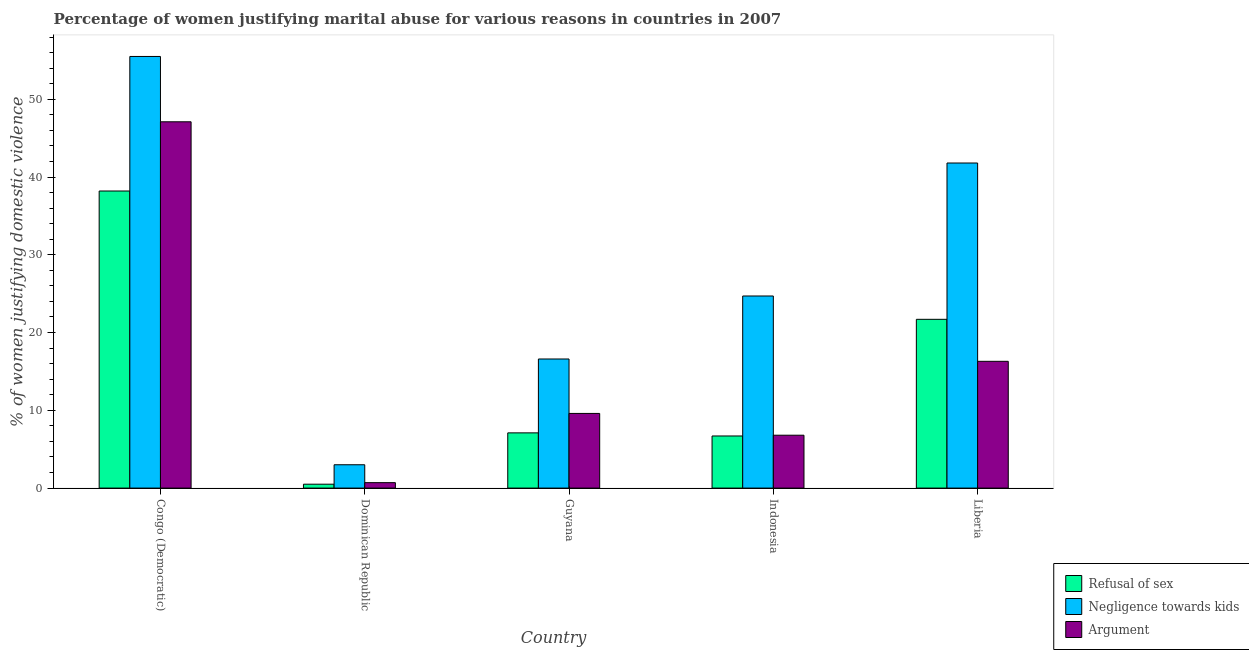How many different coloured bars are there?
Offer a terse response. 3. How many groups of bars are there?
Provide a succinct answer. 5. Are the number of bars per tick equal to the number of legend labels?
Ensure brevity in your answer.  Yes. How many bars are there on the 5th tick from the left?
Provide a short and direct response. 3. How many bars are there on the 3rd tick from the right?
Offer a terse response. 3. What is the label of the 2nd group of bars from the left?
Ensure brevity in your answer.  Dominican Republic. Across all countries, what is the maximum percentage of women justifying domestic violence due to negligence towards kids?
Provide a succinct answer. 55.5. Across all countries, what is the minimum percentage of women justifying domestic violence due to arguments?
Keep it short and to the point. 0.7. In which country was the percentage of women justifying domestic violence due to arguments maximum?
Ensure brevity in your answer.  Congo (Democratic). In which country was the percentage of women justifying domestic violence due to arguments minimum?
Your answer should be compact. Dominican Republic. What is the total percentage of women justifying domestic violence due to arguments in the graph?
Your answer should be compact. 80.5. What is the difference between the percentage of women justifying domestic violence due to refusal of sex in Indonesia and the percentage of women justifying domestic violence due to arguments in Congo (Democratic)?
Make the answer very short. -40.4. What is the ratio of the percentage of women justifying domestic violence due to arguments in Congo (Democratic) to that in Guyana?
Ensure brevity in your answer.  4.91. What is the difference between the highest and the second highest percentage of women justifying domestic violence due to negligence towards kids?
Your response must be concise. 13.7. What is the difference between the highest and the lowest percentage of women justifying domestic violence due to refusal of sex?
Ensure brevity in your answer.  37.7. Is the sum of the percentage of women justifying domestic violence due to arguments in Dominican Republic and Guyana greater than the maximum percentage of women justifying domestic violence due to refusal of sex across all countries?
Provide a succinct answer. No. What does the 1st bar from the left in Indonesia represents?
Make the answer very short. Refusal of sex. What does the 3rd bar from the right in Dominican Republic represents?
Provide a succinct answer. Refusal of sex. What is the difference between two consecutive major ticks on the Y-axis?
Offer a very short reply. 10. Does the graph contain any zero values?
Ensure brevity in your answer.  No. Does the graph contain grids?
Provide a short and direct response. No. How are the legend labels stacked?
Make the answer very short. Vertical. What is the title of the graph?
Your answer should be compact. Percentage of women justifying marital abuse for various reasons in countries in 2007. Does "Food" appear as one of the legend labels in the graph?
Give a very brief answer. No. What is the label or title of the X-axis?
Ensure brevity in your answer.  Country. What is the label or title of the Y-axis?
Make the answer very short. % of women justifying domestic violence. What is the % of women justifying domestic violence in Refusal of sex in Congo (Democratic)?
Offer a very short reply. 38.2. What is the % of women justifying domestic violence of Negligence towards kids in Congo (Democratic)?
Provide a succinct answer. 55.5. What is the % of women justifying domestic violence in Argument in Congo (Democratic)?
Your response must be concise. 47.1. What is the % of women justifying domestic violence in Refusal of sex in Dominican Republic?
Your answer should be very brief. 0.5. What is the % of women justifying domestic violence of Argument in Dominican Republic?
Offer a very short reply. 0.7. What is the % of women justifying domestic violence of Negligence towards kids in Guyana?
Ensure brevity in your answer.  16.6. What is the % of women justifying domestic violence of Refusal of sex in Indonesia?
Your answer should be very brief. 6.7. What is the % of women justifying domestic violence of Negligence towards kids in Indonesia?
Ensure brevity in your answer.  24.7. What is the % of women justifying domestic violence in Argument in Indonesia?
Your response must be concise. 6.8. What is the % of women justifying domestic violence in Refusal of sex in Liberia?
Your response must be concise. 21.7. What is the % of women justifying domestic violence of Negligence towards kids in Liberia?
Provide a succinct answer. 41.8. Across all countries, what is the maximum % of women justifying domestic violence of Refusal of sex?
Your answer should be very brief. 38.2. Across all countries, what is the maximum % of women justifying domestic violence in Negligence towards kids?
Offer a very short reply. 55.5. Across all countries, what is the maximum % of women justifying domestic violence of Argument?
Provide a short and direct response. 47.1. Across all countries, what is the minimum % of women justifying domestic violence of Refusal of sex?
Make the answer very short. 0.5. What is the total % of women justifying domestic violence of Refusal of sex in the graph?
Your response must be concise. 74.2. What is the total % of women justifying domestic violence in Negligence towards kids in the graph?
Keep it short and to the point. 141.6. What is the total % of women justifying domestic violence in Argument in the graph?
Provide a short and direct response. 80.5. What is the difference between the % of women justifying domestic violence of Refusal of sex in Congo (Democratic) and that in Dominican Republic?
Provide a succinct answer. 37.7. What is the difference between the % of women justifying domestic violence of Negligence towards kids in Congo (Democratic) and that in Dominican Republic?
Ensure brevity in your answer.  52.5. What is the difference between the % of women justifying domestic violence of Argument in Congo (Democratic) and that in Dominican Republic?
Offer a terse response. 46.4. What is the difference between the % of women justifying domestic violence in Refusal of sex in Congo (Democratic) and that in Guyana?
Provide a short and direct response. 31.1. What is the difference between the % of women justifying domestic violence in Negligence towards kids in Congo (Democratic) and that in Guyana?
Offer a very short reply. 38.9. What is the difference between the % of women justifying domestic violence of Argument in Congo (Democratic) and that in Guyana?
Offer a terse response. 37.5. What is the difference between the % of women justifying domestic violence of Refusal of sex in Congo (Democratic) and that in Indonesia?
Provide a succinct answer. 31.5. What is the difference between the % of women justifying domestic violence in Negligence towards kids in Congo (Democratic) and that in Indonesia?
Offer a very short reply. 30.8. What is the difference between the % of women justifying domestic violence of Argument in Congo (Democratic) and that in Indonesia?
Provide a short and direct response. 40.3. What is the difference between the % of women justifying domestic violence of Negligence towards kids in Congo (Democratic) and that in Liberia?
Make the answer very short. 13.7. What is the difference between the % of women justifying domestic violence in Argument in Congo (Democratic) and that in Liberia?
Offer a terse response. 30.8. What is the difference between the % of women justifying domestic violence in Refusal of sex in Dominican Republic and that in Guyana?
Give a very brief answer. -6.6. What is the difference between the % of women justifying domestic violence in Negligence towards kids in Dominican Republic and that in Indonesia?
Provide a succinct answer. -21.7. What is the difference between the % of women justifying domestic violence in Refusal of sex in Dominican Republic and that in Liberia?
Ensure brevity in your answer.  -21.2. What is the difference between the % of women justifying domestic violence of Negligence towards kids in Dominican Republic and that in Liberia?
Your answer should be very brief. -38.8. What is the difference between the % of women justifying domestic violence of Argument in Dominican Republic and that in Liberia?
Your answer should be very brief. -15.6. What is the difference between the % of women justifying domestic violence of Negligence towards kids in Guyana and that in Indonesia?
Make the answer very short. -8.1. What is the difference between the % of women justifying domestic violence of Refusal of sex in Guyana and that in Liberia?
Make the answer very short. -14.6. What is the difference between the % of women justifying domestic violence in Negligence towards kids in Guyana and that in Liberia?
Provide a succinct answer. -25.2. What is the difference between the % of women justifying domestic violence in Argument in Guyana and that in Liberia?
Keep it short and to the point. -6.7. What is the difference between the % of women justifying domestic violence of Refusal of sex in Indonesia and that in Liberia?
Give a very brief answer. -15. What is the difference between the % of women justifying domestic violence of Negligence towards kids in Indonesia and that in Liberia?
Give a very brief answer. -17.1. What is the difference between the % of women justifying domestic violence in Refusal of sex in Congo (Democratic) and the % of women justifying domestic violence in Negligence towards kids in Dominican Republic?
Your response must be concise. 35.2. What is the difference between the % of women justifying domestic violence in Refusal of sex in Congo (Democratic) and the % of women justifying domestic violence in Argument in Dominican Republic?
Give a very brief answer. 37.5. What is the difference between the % of women justifying domestic violence in Negligence towards kids in Congo (Democratic) and the % of women justifying domestic violence in Argument in Dominican Republic?
Provide a short and direct response. 54.8. What is the difference between the % of women justifying domestic violence of Refusal of sex in Congo (Democratic) and the % of women justifying domestic violence of Negligence towards kids in Guyana?
Keep it short and to the point. 21.6. What is the difference between the % of women justifying domestic violence of Refusal of sex in Congo (Democratic) and the % of women justifying domestic violence of Argument in Guyana?
Offer a very short reply. 28.6. What is the difference between the % of women justifying domestic violence of Negligence towards kids in Congo (Democratic) and the % of women justifying domestic violence of Argument in Guyana?
Provide a succinct answer. 45.9. What is the difference between the % of women justifying domestic violence of Refusal of sex in Congo (Democratic) and the % of women justifying domestic violence of Argument in Indonesia?
Your response must be concise. 31.4. What is the difference between the % of women justifying domestic violence in Negligence towards kids in Congo (Democratic) and the % of women justifying domestic violence in Argument in Indonesia?
Offer a very short reply. 48.7. What is the difference between the % of women justifying domestic violence of Refusal of sex in Congo (Democratic) and the % of women justifying domestic violence of Argument in Liberia?
Keep it short and to the point. 21.9. What is the difference between the % of women justifying domestic violence of Negligence towards kids in Congo (Democratic) and the % of women justifying domestic violence of Argument in Liberia?
Give a very brief answer. 39.2. What is the difference between the % of women justifying domestic violence in Refusal of sex in Dominican Republic and the % of women justifying domestic violence in Negligence towards kids in Guyana?
Give a very brief answer. -16.1. What is the difference between the % of women justifying domestic violence of Refusal of sex in Dominican Republic and the % of women justifying domestic violence of Argument in Guyana?
Offer a very short reply. -9.1. What is the difference between the % of women justifying domestic violence of Refusal of sex in Dominican Republic and the % of women justifying domestic violence of Negligence towards kids in Indonesia?
Give a very brief answer. -24.2. What is the difference between the % of women justifying domestic violence of Refusal of sex in Dominican Republic and the % of women justifying domestic violence of Argument in Indonesia?
Your answer should be very brief. -6.3. What is the difference between the % of women justifying domestic violence in Refusal of sex in Dominican Republic and the % of women justifying domestic violence in Negligence towards kids in Liberia?
Provide a succinct answer. -41.3. What is the difference between the % of women justifying domestic violence of Refusal of sex in Dominican Republic and the % of women justifying domestic violence of Argument in Liberia?
Ensure brevity in your answer.  -15.8. What is the difference between the % of women justifying domestic violence of Negligence towards kids in Dominican Republic and the % of women justifying domestic violence of Argument in Liberia?
Your response must be concise. -13.3. What is the difference between the % of women justifying domestic violence in Refusal of sex in Guyana and the % of women justifying domestic violence in Negligence towards kids in Indonesia?
Offer a very short reply. -17.6. What is the difference between the % of women justifying domestic violence of Negligence towards kids in Guyana and the % of women justifying domestic violence of Argument in Indonesia?
Ensure brevity in your answer.  9.8. What is the difference between the % of women justifying domestic violence in Refusal of sex in Guyana and the % of women justifying domestic violence in Negligence towards kids in Liberia?
Give a very brief answer. -34.7. What is the difference between the % of women justifying domestic violence in Negligence towards kids in Guyana and the % of women justifying domestic violence in Argument in Liberia?
Make the answer very short. 0.3. What is the difference between the % of women justifying domestic violence in Refusal of sex in Indonesia and the % of women justifying domestic violence in Negligence towards kids in Liberia?
Keep it short and to the point. -35.1. What is the difference between the % of women justifying domestic violence of Negligence towards kids in Indonesia and the % of women justifying domestic violence of Argument in Liberia?
Make the answer very short. 8.4. What is the average % of women justifying domestic violence of Refusal of sex per country?
Your answer should be very brief. 14.84. What is the average % of women justifying domestic violence of Negligence towards kids per country?
Your response must be concise. 28.32. What is the difference between the % of women justifying domestic violence of Refusal of sex and % of women justifying domestic violence of Negligence towards kids in Congo (Democratic)?
Provide a succinct answer. -17.3. What is the difference between the % of women justifying domestic violence of Refusal of sex and % of women justifying domestic violence of Argument in Congo (Democratic)?
Your response must be concise. -8.9. What is the difference between the % of women justifying domestic violence in Refusal of sex and % of women justifying domestic violence in Argument in Dominican Republic?
Give a very brief answer. -0.2. What is the difference between the % of women justifying domestic violence of Negligence towards kids and % of women justifying domestic violence of Argument in Dominican Republic?
Your answer should be compact. 2.3. What is the difference between the % of women justifying domestic violence of Refusal of sex and % of women justifying domestic violence of Negligence towards kids in Guyana?
Ensure brevity in your answer.  -9.5. What is the difference between the % of women justifying domestic violence in Negligence towards kids and % of women justifying domestic violence in Argument in Guyana?
Provide a succinct answer. 7. What is the difference between the % of women justifying domestic violence in Refusal of sex and % of women justifying domestic violence in Negligence towards kids in Indonesia?
Offer a terse response. -18. What is the difference between the % of women justifying domestic violence of Refusal of sex and % of women justifying domestic violence of Negligence towards kids in Liberia?
Keep it short and to the point. -20.1. What is the ratio of the % of women justifying domestic violence in Refusal of sex in Congo (Democratic) to that in Dominican Republic?
Make the answer very short. 76.4. What is the ratio of the % of women justifying domestic violence of Negligence towards kids in Congo (Democratic) to that in Dominican Republic?
Your response must be concise. 18.5. What is the ratio of the % of women justifying domestic violence in Argument in Congo (Democratic) to that in Dominican Republic?
Provide a succinct answer. 67.29. What is the ratio of the % of women justifying domestic violence of Refusal of sex in Congo (Democratic) to that in Guyana?
Offer a very short reply. 5.38. What is the ratio of the % of women justifying domestic violence of Negligence towards kids in Congo (Democratic) to that in Guyana?
Give a very brief answer. 3.34. What is the ratio of the % of women justifying domestic violence in Argument in Congo (Democratic) to that in Guyana?
Provide a succinct answer. 4.91. What is the ratio of the % of women justifying domestic violence of Refusal of sex in Congo (Democratic) to that in Indonesia?
Make the answer very short. 5.7. What is the ratio of the % of women justifying domestic violence in Negligence towards kids in Congo (Democratic) to that in Indonesia?
Your answer should be very brief. 2.25. What is the ratio of the % of women justifying domestic violence of Argument in Congo (Democratic) to that in Indonesia?
Offer a terse response. 6.93. What is the ratio of the % of women justifying domestic violence in Refusal of sex in Congo (Democratic) to that in Liberia?
Your answer should be very brief. 1.76. What is the ratio of the % of women justifying domestic violence of Negligence towards kids in Congo (Democratic) to that in Liberia?
Your response must be concise. 1.33. What is the ratio of the % of women justifying domestic violence in Argument in Congo (Democratic) to that in Liberia?
Give a very brief answer. 2.89. What is the ratio of the % of women justifying domestic violence of Refusal of sex in Dominican Republic to that in Guyana?
Keep it short and to the point. 0.07. What is the ratio of the % of women justifying domestic violence of Negligence towards kids in Dominican Republic to that in Guyana?
Your response must be concise. 0.18. What is the ratio of the % of women justifying domestic violence of Argument in Dominican Republic to that in Guyana?
Make the answer very short. 0.07. What is the ratio of the % of women justifying domestic violence of Refusal of sex in Dominican Republic to that in Indonesia?
Offer a very short reply. 0.07. What is the ratio of the % of women justifying domestic violence of Negligence towards kids in Dominican Republic to that in Indonesia?
Your response must be concise. 0.12. What is the ratio of the % of women justifying domestic violence in Argument in Dominican Republic to that in Indonesia?
Give a very brief answer. 0.1. What is the ratio of the % of women justifying domestic violence of Refusal of sex in Dominican Republic to that in Liberia?
Provide a short and direct response. 0.02. What is the ratio of the % of women justifying domestic violence of Negligence towards kids in Dominican Republic to that in Liberia?
Offer a terse response. 0.07. What is the ratio of the % of women justifying domestic violence in Argument in Dominican Republic to that in Liberia?
Keep it short and to the point. 0.04. What is the ratio of the % of women justifying domestic violence of Refusal of sex in Guyana to that in Indonesia?
Offer a very short reply. 1.06. What is the ratio of the % of women justifying domestic violence of Negligence towards kids in Guyana to that in Indonesia?
Offer a terse response. 0.67. What is the ratio of the % of women justifying domestic violence of Argument in Guyana to that in Indonesia?
Ensure brevity in your answer.  1.41. What is the ratio of the % of women justifying domestic violence of Refusal of sex in Guyana to that in Liberia?
Give a very brief answer. 0.33. What is the ratio of the % of women justifying domestic violence of Negligence towards kids in Guyana to that in Liberia?
Your response must be concise. 0.4. What is the ratio of the % of women justifying domestic violence of Argument in Guyana to that in Liberia?
Provide a short and direct response. 0.59. What is the ratio of the % of women justifying domestic violence in Refusal of sex in Indonesia to that in Liberia?
Provide a succinct answer. 0.31. What is the ratio of the % of women justifying domestic violence of Negligence towards kids in Indonesia to that in Liberia?
Make the answer very short. 0.59. What is the ratio of the % of women justifying domestic violence in Argument in Indonesia to that in Liberia?
Offer a very short reply. 0.42. What is the difference between the highest and the second highest % of women justifying domestic violence in Refusal of sex?
Your response must be concise. 16.5. What is the difference between the highest and the second highest % of women justifying domestic violence in Negligence towards kids?
Your response must be concise. 13.7. What is the difference between the highest and the second highest % of women justifying domestic violence in Argument?
Provide a succinct answer. 30.8. What is the difference between the highest and the lowest % of women justifying domestic violence of Refusal of sex?
Give a very brief answer. 37.7. What is the difference between the highest and the lowest % of women justifying domestic violence of Negligence towards kids?
Provide a succinct answer. 52.5. What is the difference between the highest and the lowest % of women justifying domestic violence of Argument?
Make the answer very short. 46.4. 